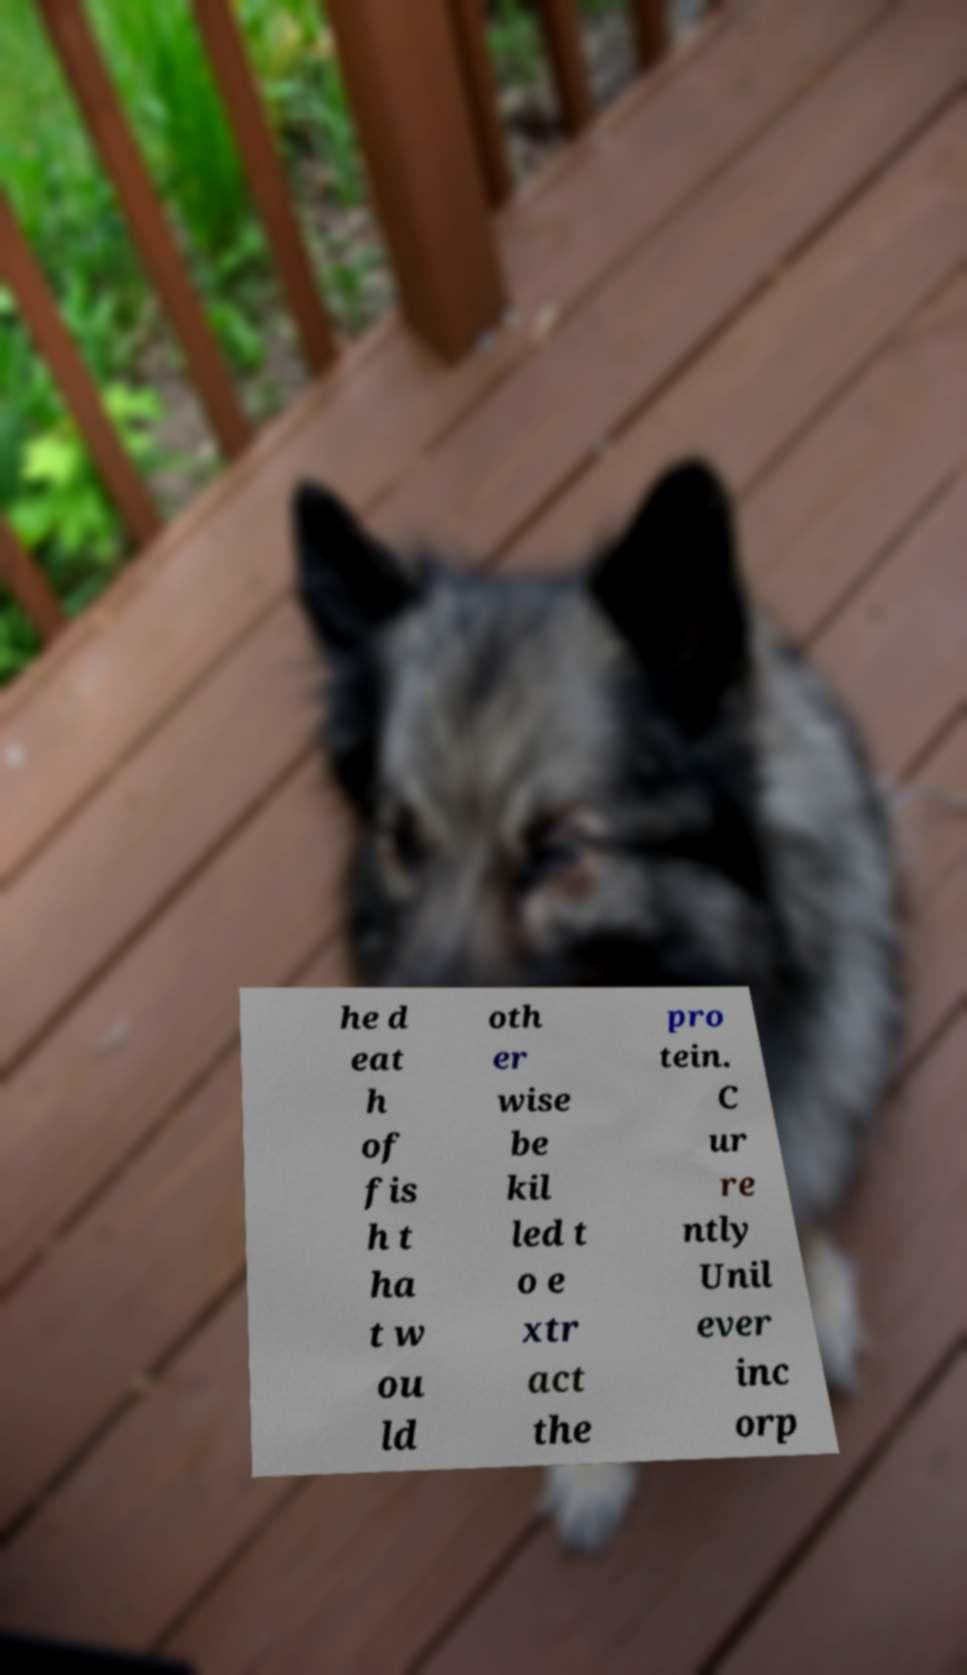What messages or text are displayed in this image? I need them in a readable, typed format. he d eat h of fis h t ha t w ou ld oth er wise be kil led t o e xtr act the pro tein. C ur re ntly Unil ever inc orp 